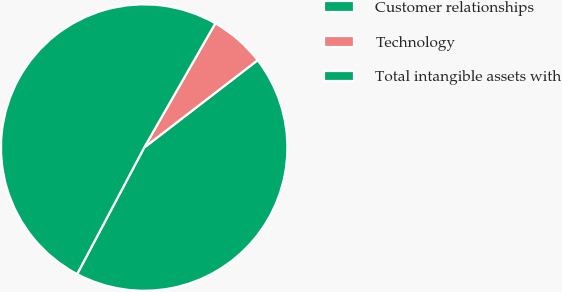Convert chart to OTSL. <chart><loc_0><loc_0><loc_500><loc_500><pie_chart><fcel>Customer relationships<fcel>Technology<fcel>Total intangible assets with<nl><fcel>43.2%<fcel>6.28%<fcel>50.52%<nl></chart> 